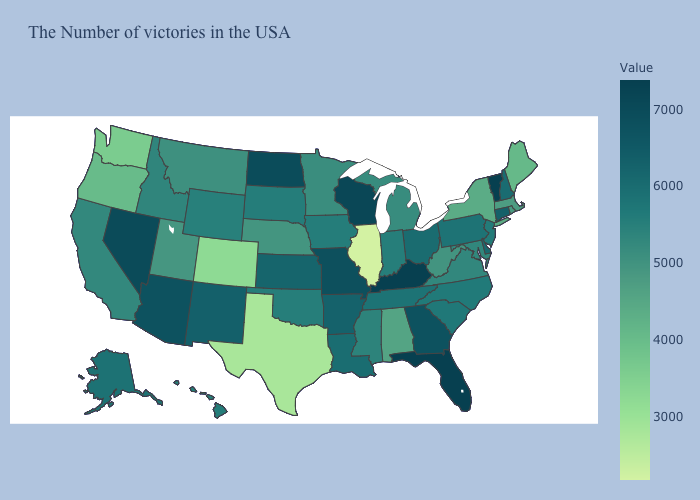Does New Hampshire have the highest value in the Northeast?
Be succinct. No. Which states hav the highest value in the West?
Answer briefly. Nevada. Which states have the highest value in the USA?
Write a very short answer. Vermont, Florida, Kentucky. Among the states that border Michigan , does Indiana have the lowest value?
Write a very short answer. Yes. Is the legend a continuous bar?
Be succinct. Yes. Which states have the highest value in the USA?
Keep it brief. Vermont, Florida, Kentucky. 